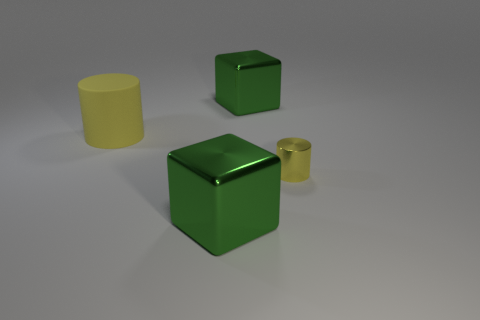There is a cube that is in front of the cylinder that is to the left of the block behind the large yellow rubber cylinder; what size is it?
Give a very brief answer. Large. There is a green metal thing behind the matte cylinder; what is its size?
Ensure brevity in your answer.  Large. Is the material of the big yellow cylinder behind the yellow metallic cylinder the same as the tiny yellow object?
Provide a succinct answer. No. What number of other things are there of the same material as the tiny yellow object
Provide a succinct answer. 2. How many things are big blocks behind the small yellow metal cylinder or large blocks that are behind the big yellow object?
Keep it short and to the point. 1. There is a green metal thing behind the large yellow object; is its shape the same as the large green thing in front of the large yellow object?
Make the answer very short. Yes. How many rubber objects are either yellow cylinders or tiny objects?
Provide a short and direct response. 1. Does the object in front of the metallic cylinder have the same material as the yellow cylinder that is on the left side of the small cylinder?
Make the answer very short. No. Is the number of big yellow cylinders that are behind the large yellow rubber cylinder greater than the number of yellow metal cylinders behind the tiny metallic object?
Give a very brief answer. No. Is there a metallic cube?
Make the answer very short. Yes. 